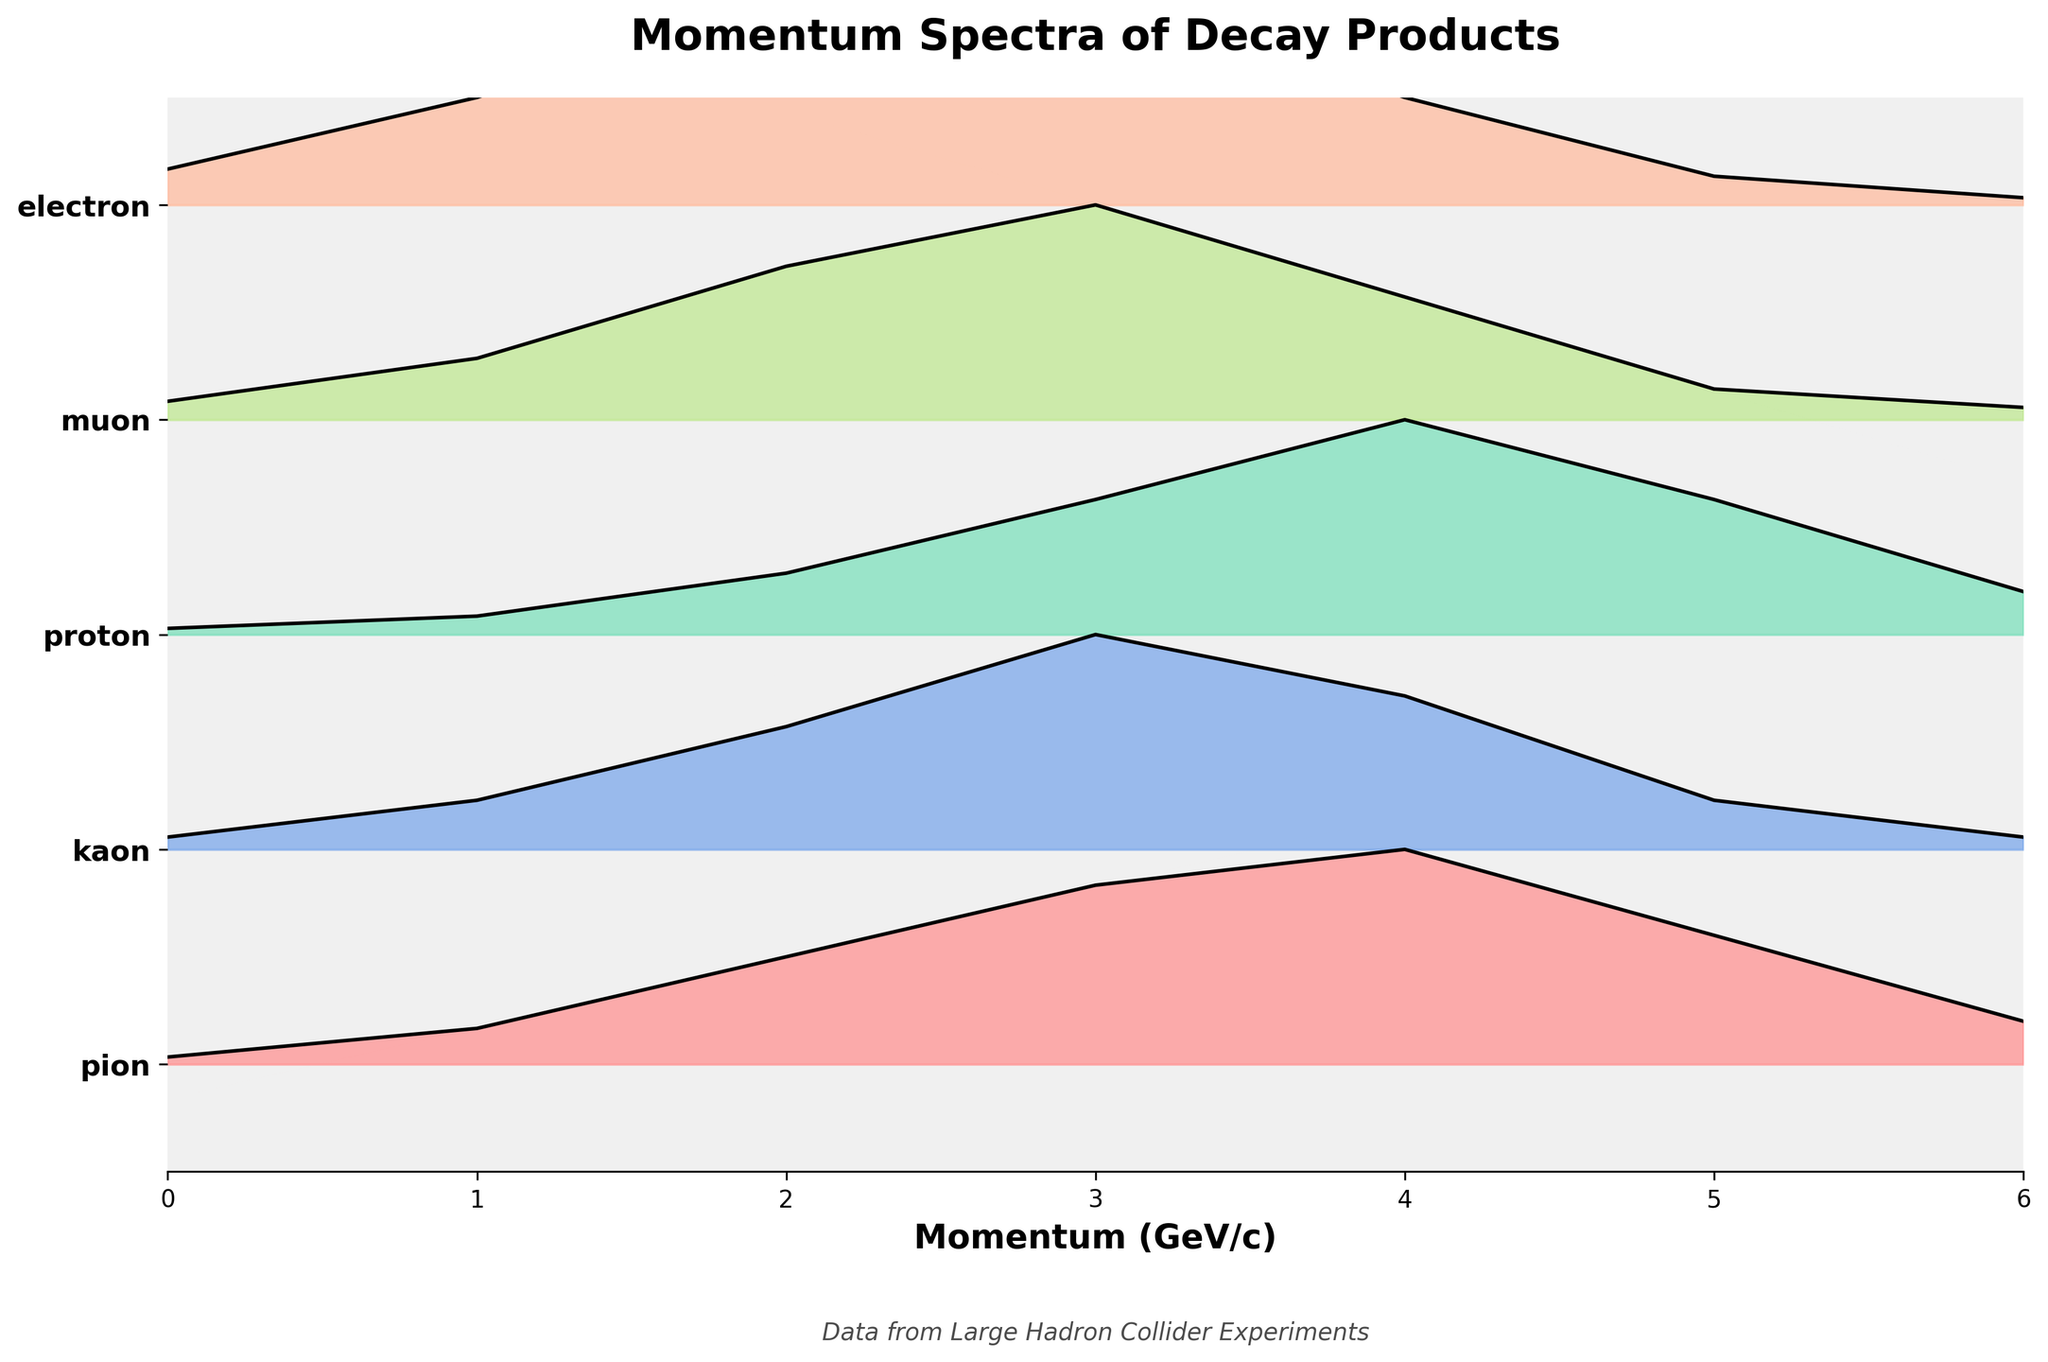What is the title of the figure? The title is typically displayed at the top of the figure in bold. In this case, it reads "Momentum Spectra of Decay Products".
Answer: Momentum Spectra of Decay Products How many types of particles are shown in the plot? The y-axis displays the particles involved in the plot. By counting the categories listed on the y-axis tick marks, we see there are five types of particles.
Answer: Five Which particle shows the highest maximum density? By observing the peak heights of the ridgelines for each particle, the kaon has the highest peak.
Answer: Kaon At what momentum does the pion reach its maximum density? The pion's maximum density can be identified by looking at the momentum value along the x-axis where the pion ridgeline reaches its peak. The peak occurs at momentum 4.
Answer: Momentum 4 How do the momentum density distributions compare between the proton and the electron? By comparing the ridgelines of the proton and the electron, you can see that the proton’s peak is at momentum 4, while the electron has a wider distribution with a peak spanning across momenta 2 and 3.
Answer: Proton peak at 4, Electron peak across 2 and 3 What is the trend in momentum peaks across all particles? By looking sequentially at each particle's peak, you can observe that while the specific peak momentum values vary, many particles reach their maximum density around momentum 3 or 4.
Answer: Many peak around 3 or 4 Which particle has the broadest density distribution? The electron’s ridgeline is the widest, indicating that it has the broadest density distribution as it spans from low to high momentum values.
Answer: Electron How do the density values for kaon compare between momenta 2 and 5? From the ridgeline, kaon's density at momentum 2 is higher than at momentum 5. Specifically, around 0.20 at momentum 2 and 0.08 at momentum 5.
Answer: Density at 2 is 0.20, at 5 is 0.08 What might be inferred about decay processes from the relative heights of the ridgelines? Higher ridgeline peaks suggest a higher probability of decay products having certain momentum values. Kaons have the highest peak, suggesting that kaon decay products more frequently have peak momentum values compared to others.
Answer: Higher likelihood for kaon states 